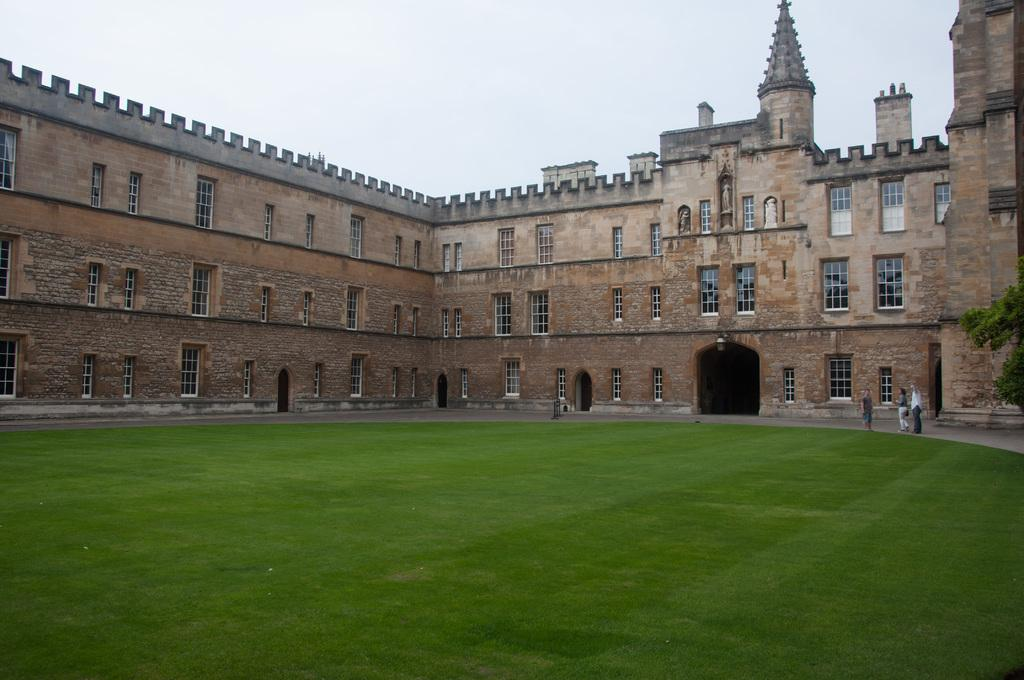What is the main structure in the image? There is a castle in the image. What feature can be observed on the castle? The castle has many windows. What type of landscape is in front of the castle? There is grassland in front of the castle. What is visible above the castle? The sky is visible above the castle. What is the price of the faucet in the image? There is no faucet present in the image. How many letters are visible on the castle walls in the image? There is no mention of letters on the castle walls in the image. 